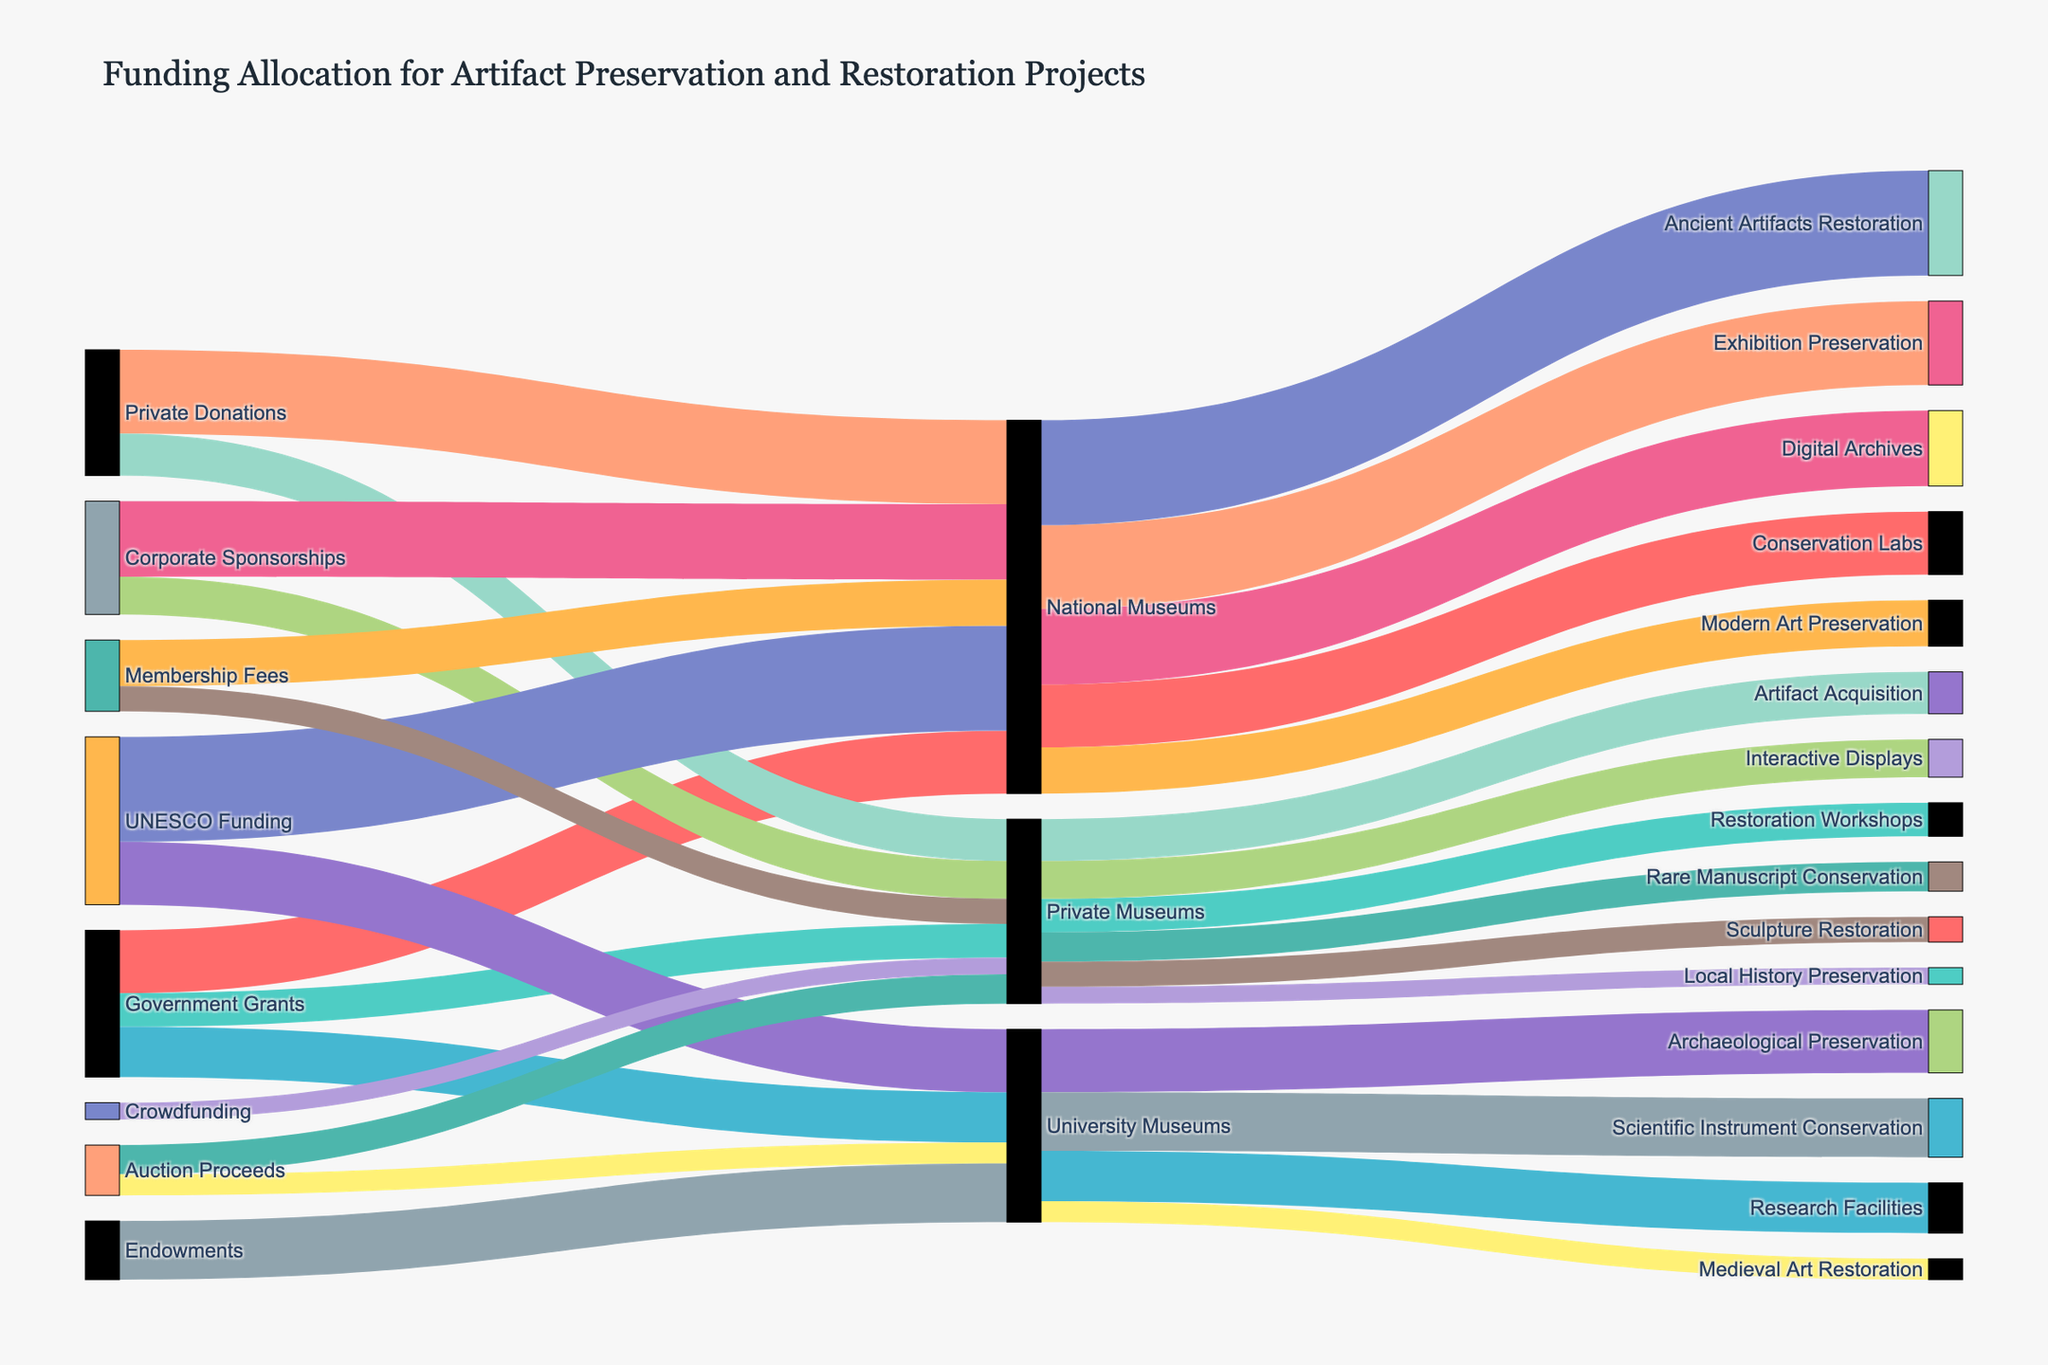What's the title of the figure? The title is the text at the top of the figure that provides a succinct summary of what the figure is about.
Answer: Funding Allocation for Artifact Preservation and Restoration Projects Which funding source contributes the most to "National Museums"? By looking at the width of the flows entering "National Museums", the flow from "UNESCO Funding" is the widest, indicating the largest contribution.
Answer: UNESCO Funding What amount is allocated to "Research Facilities" from "Government Grants"? Find the flow starting from "Government Grants" and ending in "University Museums", and then to "Research Facilities". The value at the intersection is 12.
Answer: 12 How many total funding sources are displayed in the diagram? Count the unique nodes on the left side of the diagram. There are "Government Grants", "Private Donations", "Corporate Sponsorships", "UNESCO Funding", "Auction Proceeds", "Membership Fees", "Endowments", "Crowdfunding". There are 8 funding sources.
Answer: 8 Which preservation/restoration area in "University Museums" receives the least funding? Look at the target nodes connected to "University Museums". "Medieval Art Restoration" has the smallest flow of 5.
Answer: Medieval Art Restoration Compare the total funding received by "Private Museums" and "National Museums". Which receives more? Sum the values of flows entering each one. Private Museums: 8+10+9+7+6+4 = 44. National Museums: 15+20+18+25+11 = 89. Therefore, "National Museums" receive more.
Answer: National Museums How is "Corporate Sponsorship" funding allocated to different museum types? "Corporate Sponsorship" funds are divided into "National Museums" (18 for Digital Archives) and "Private Museums" (9 for Interactive Displays).
Answer: National Museums and Private Museums What is the combined funding for "Scientific Instrument Conservation" and "Archaeological Preservation"? The values for these targets are 14 and 15, respectively. Adding them gives 14 + 15 = 29.
Answer: 29 Which intermediate node has the most diverse allocation of funds to different targets? Check the intermediate nodes connected to the maximum number of different targets. "National Museums" has funding allocated to five different targets.
Answer: National Museums How many preservation/restoration projects receive funding from "University Museums"? Count the number of different targets for "University Museums". They are "Research Facilities", "Archaeological Preservation", "Medieval Art Restoration", and "Scientific Instrument Conservation", totaling 4.
Answer: 4 